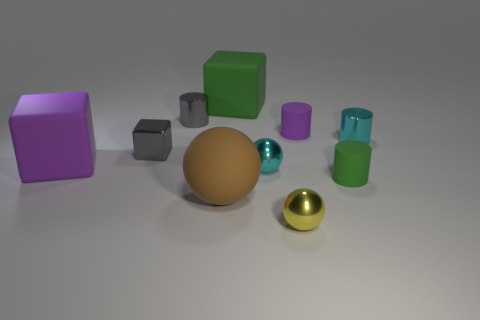What can you tell me about the textures and materials of the objects? The objects displayed in the image exhibit a range of textures and materials. The purple and green cubes have a matte finish, suggesting a more diffuse surface material. The spheres, in contrast, have highly reflective, metallic finishes, with the smaller sphere exhibiting a gold color and the other sphere showing a turquoise hue. The grey cubes are less reflective but still have a hint of shininess, which could indicate a metallic or polished stone material. 